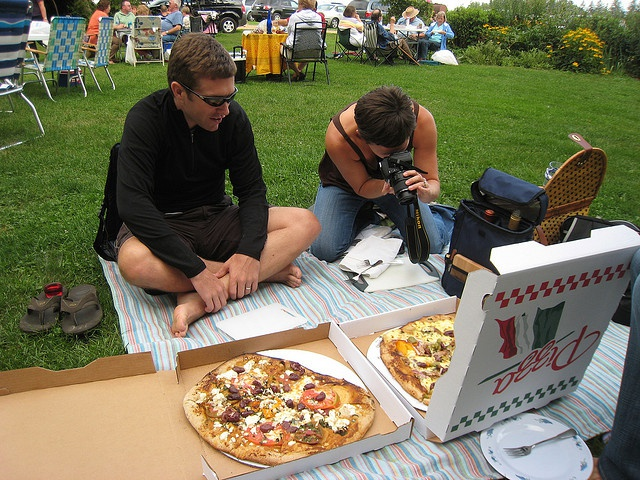Describe the objects in this image and their specific colors. I can see people in darkblue, black, salmon, and maroon tones, people in darkblue, black, maroon, and gray tones, pizza in darkblue, tan, ivory, and brown tones, backpack in darkblue, black, and gray tones, and handbag in darkblue, black, and gray tones in this image. 